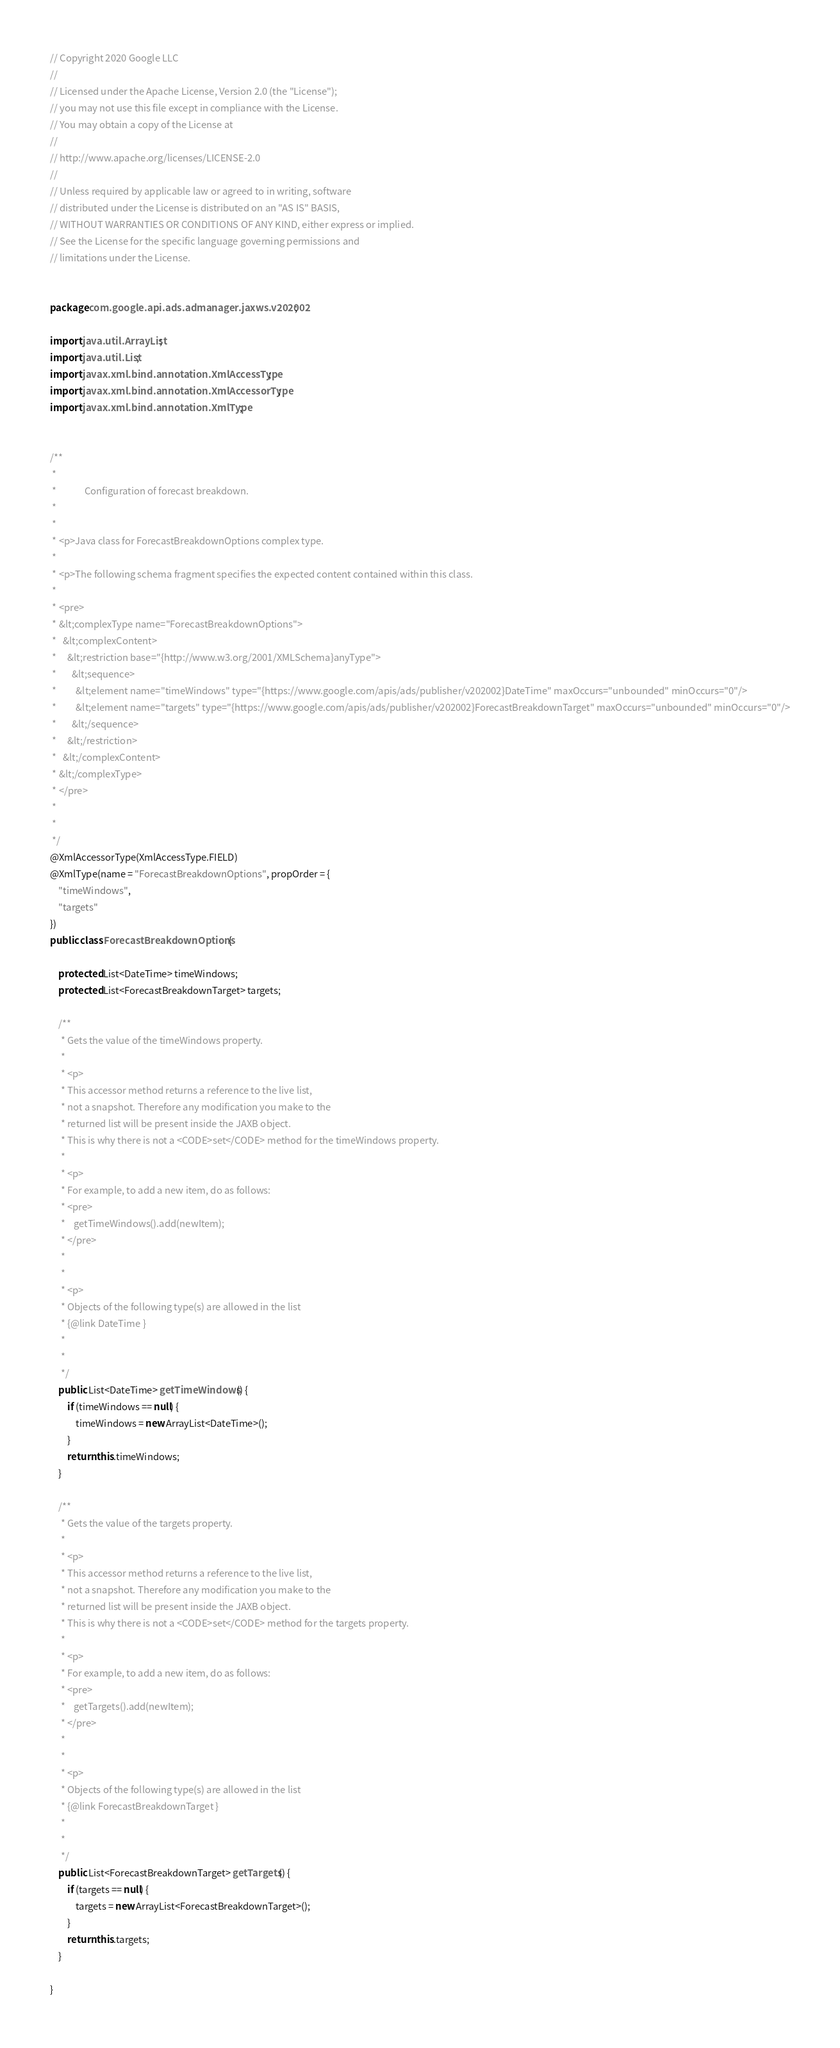<code> <loc_0><loc_0><loc_500><loc_500><_Java_>// Copyright 2020 Google LLC
//
// Licensed under the Apache License, Version 2.0 (the "License");
// you may not use this file except in compliance with the License.
// You may obtain a copy of the License at
//
// http://www.apache.org/licenses/LICENSE-2.0
//
// Unless required by applicable law or agreed to in writing, software
// distributed under the License is distributed on an "AS IS" BASIS,
// WITHOUT WARRANTIES OR CONDITIONS OF ANY KIND, either express or implied.
// See the License for the specific language governing permissions and
// limitations under the License.


package com.google.api.ads.admanager.jaxws.v202002;

import java.util.ArrayList;
import java.util.List;
import javax.xml.bind.annotation.XmlAccessType;
import javax.xml.bind.annotation.XmlAccessorType;
import javax.xml.bind.annotation.XmlType;


/**
 * 
 *             Configuration of forecast breakdown.
 *           
 * 
 * <p>Java class for ForecastBreakdownOptions complex type.
 * 
 * <p>The following schema fragment specifies the expected content contained within this class.
 * 
 * <pre>
 * &lt;complexType name="ForecastBreakdownOptions">
 *   &lt;complexContent>
 *     &lt;restriction base="{http://www.w3.org/2001/XMLSchema}anyType">
 *       &lt;sequence>
 *         &lt;element name="timeWindows" type="{https://www.google.com/apis/ads/publisher/v202002}DateTime" maxOccurs="unbounded" minOccurs="0"/>
 *         &lt;element name="targets" type="{https://www.google.com/apis/ads/publisher/v202002}ForecastBreakdownTarget" maxOccurs="unbounded" minOccurs="0"/>
 *       &lt;/sequence>
 *     &lt;/restriction>
 *   &lt;/complexContent>
 * &lt;/complexType>
 * </pre>
 * 
 * 
 */
@XmlAccessorType(XmlAccessType.FIELD)
@XmlType(name = "ForecastBreakdownOptions", propOrder = {
    "timeWindows",
    "targets"
})
public class ForecastBreakdownOptions {

    protected List<DateTime> timeWindows;
    protected List<ForecastBreakdownTarget> targets;

    /**
     * Gets the value of the timeWindows property.
     * 
     * <p>
     * This accessor method returns a reference to the live list,
     * not a snapshot. Therefore any modification you make to the
     * returned list will be present inside the JAXB object.
     * This is why there is not a <CODE>set</CODE> method for the timeWindows property.
     * 
     * <p>
     * For example, to add a new item, do as follows:
     * <pre>
     *    getTimeWindows().add(newItem);
     * </pre>
     * 
     * 
     * <p>
     * Objects of the following type(s) are allowed in the list
     * {@link DateTime }
     * 
     * 
     */
    public List<DateTime> getTimeWindows() {
        if (timeWindows == null) {
            timeWindows = new ArrayList<DateTime>();
        }
        return this.timeWindows;
    }

    /**
     * Gets the value of the targets property.
     * 
     * <p>
     * This accessor method returns a reference to the live list,
     * not a snapshot. Therefore any modification you make to the
     * returned list will be present inside the JAXB object.
     * This is why there is not a <CODE>set</CODE> method for the targets property.
     * 
     * <p>
     * For example, to add a new item, do as follows:
     * <pre>
     *    getTargets().add(newItem);
     * </pre>
     * 
     * 
     * <p>
     * Objects of the following type(s) are allowed in the list
     * {@link ForecastBreakdownTarget }
     * 
     * 
     */
    public List<ForecastBreakdownTarget> getTargets() {
        if (targets == null) {
            targets = new ArrayList<ForecastBreakdownTarget>();
        }
        return this.targets;
    }

}
</code> 